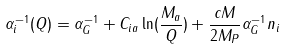<formula> <loc_0><loc_0><loc_500><loc_500>\alpha _ { i } ^ { - 1 } ( Q ) = \alpha _ { G } ^ { - 1 } + C _ { i a } \ln ( \frac { M _ { a } } { Q } ) + \frac { c M } { 2 M _ { P } } \alpha _ { G } ^ { - 1 } n _ { i }</formula> 